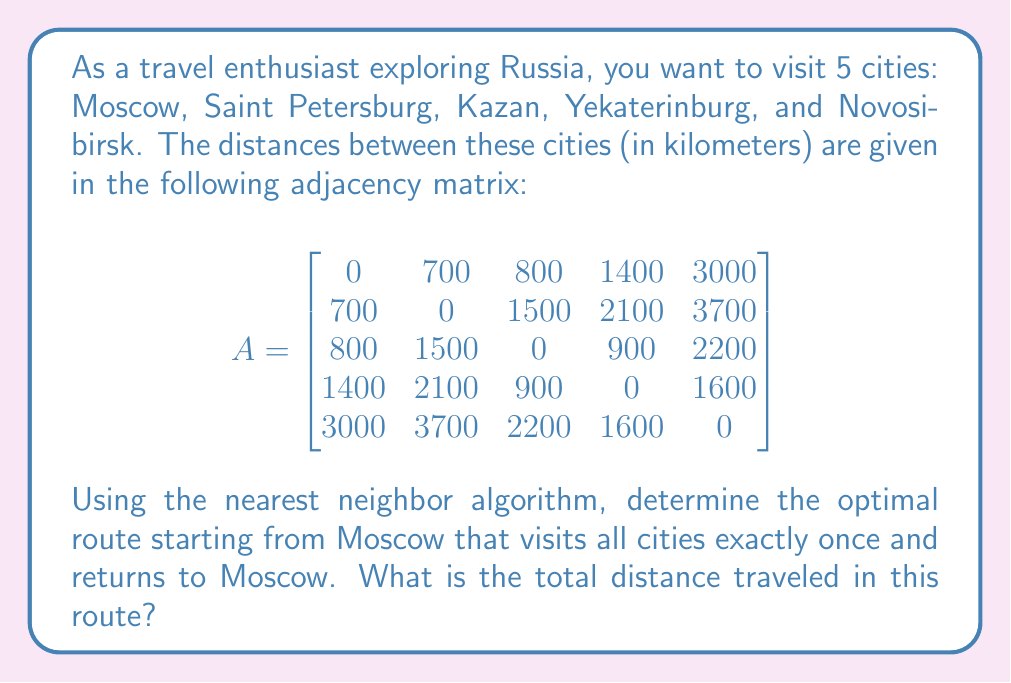Can you answer this question? To solve this problem, we'll use the nearest neighbor algorithm, which is a simple heuristic for the Traveling Salesman Problem. Here's how we'll proceed:

1) Start with Moscow (index 0 in the matrix).

2) Find the nearest unvisited city:
   - From Moscow: min(700, 800, 1400, 3000) = 700 (Saint Petersburg)

3) Move to Saint Petersburg (index 1) and repeat:
   - From Saint Petersburg: min(1500, 2100, 3700) = 1500 (Kazan)

4) Move to Kazan (index 2) and repeat:
   - From Kazan: min(900, 2200) = 900 (Yekaterinburg)

5) Move to Yekaterinburg (index 3) and repeat:
   - From Yekaterinburg: min(1600) = 1600 (Novosibirsk)

6) Move to Novosibirsk (index 4).

7) Return to Moscow from Novosibirsk.

The route is: Moscow → Saint Petersburg → Kazan → Yekaterinburg → Novosibirsk → Moscow

To calculate the total distance:
- Moscow to Saint Petersburg: 700 km
- Saint Petersburg to Kazan: 1500 km
- Kazan to Yekaterinburg: 900 km
- Yekaterinburg to Novosibirsk: 1600 km
- Novosibirsk back to Moscow: 3000 km

Total distance = 700 + 1500 + 900 + 1600 + 3000 = 7700 km
Answer: The optimal route using the nearest neighbor algorithm is Moscow → Saint Petersburg → Kazan → Yekaterinburg → Novosibirsk → Moscow, with a total distance of 7700 km. 